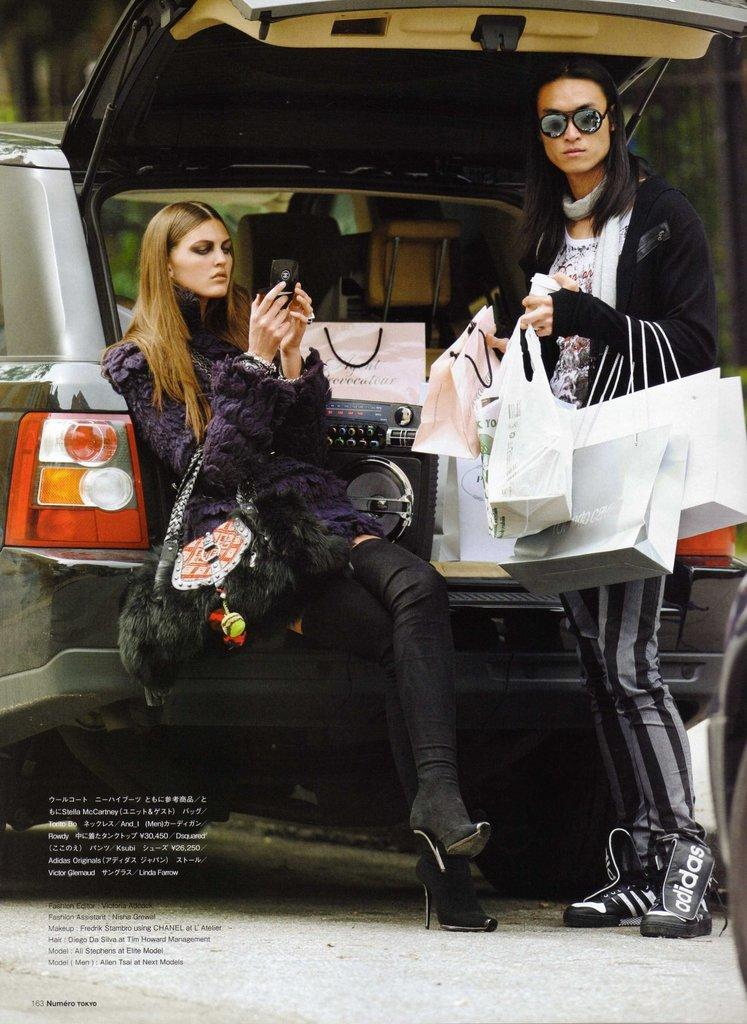What is the woman doing in the image? A: There is a woman sitting in the image. Who is with the woman in the image? There is a man standing beside the woman. What is the man holding in the image? The man is holding bags. What can be seen in the background of the image? There is a car visible in the background of the image. How does the nut feel about the comfort of the car in the image? There is no nut present in the image, and therefore no such feelings can be attributed to it. 